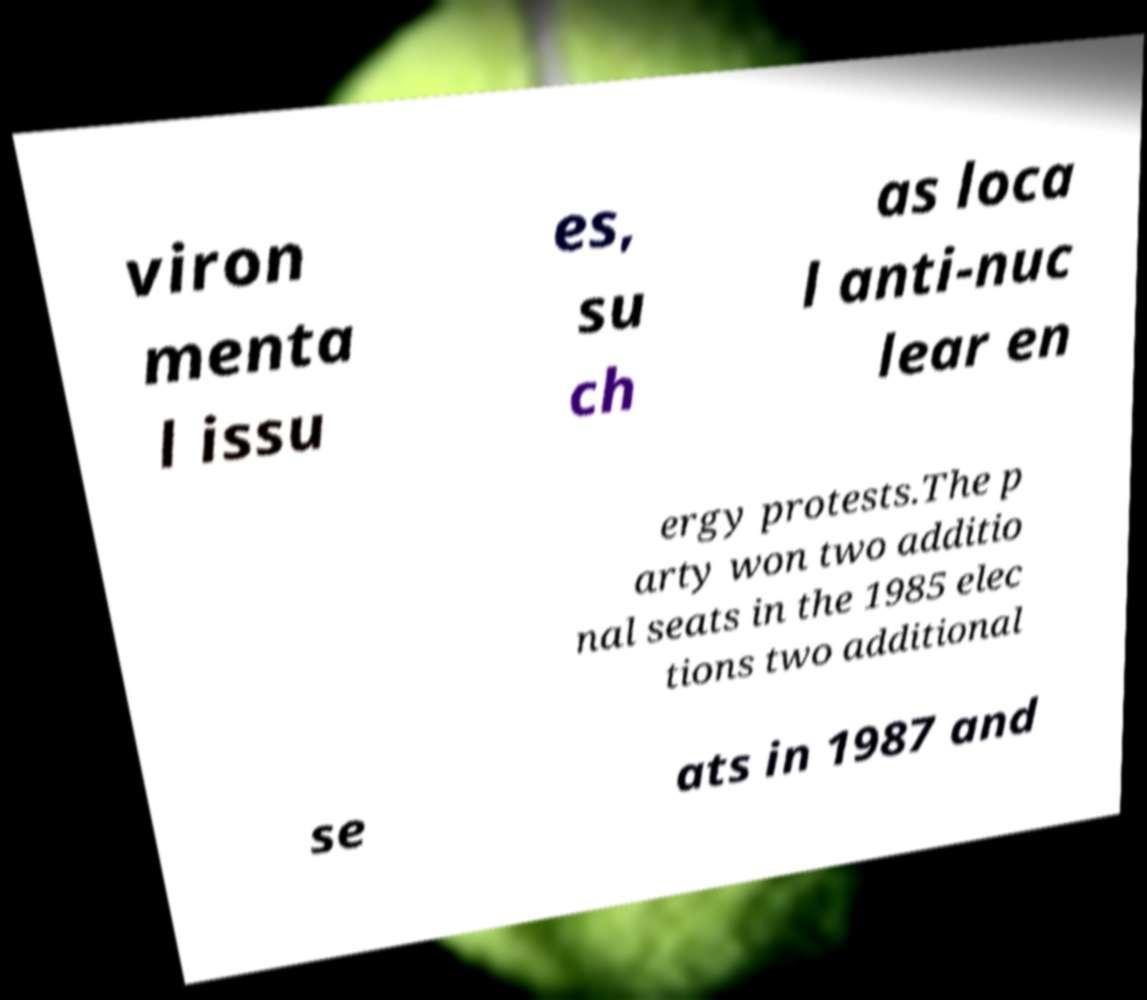For documentation purposes, I need the text within this image transcribed. Could you provide that? viron menta l issu es, su ch as loca l anti-nuc lear en ergy protests.The p arty won two additio nal seats in the 1985 elec tions two additional se ats in 1987 and 